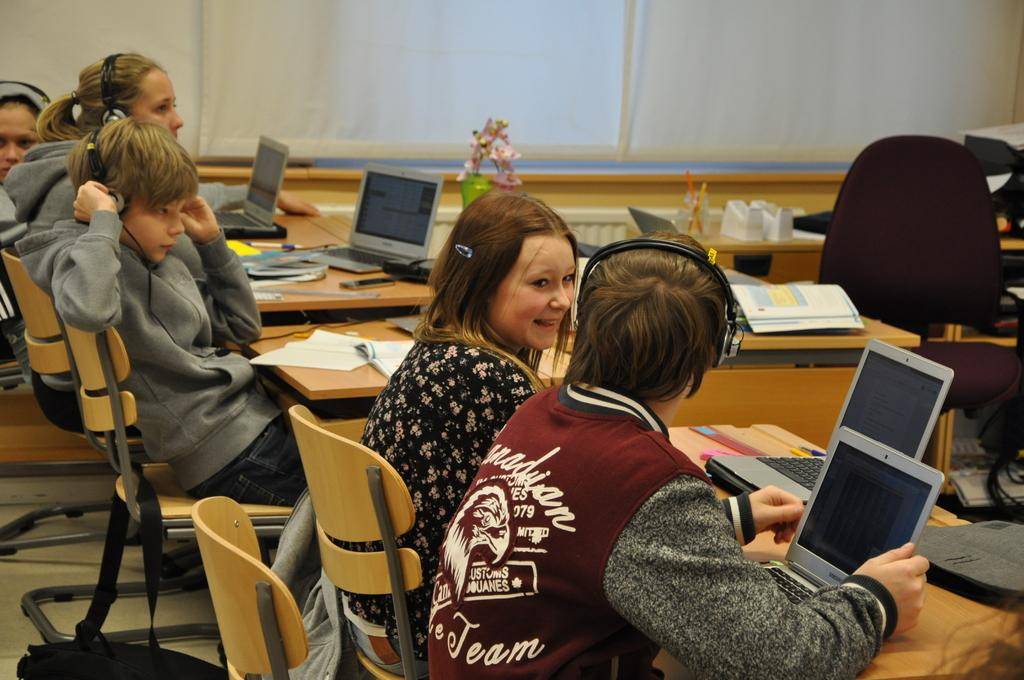What type of room is shown in the image? The image is taken in a classroom. What furniture is present in the classroom? There are tables and chairs in the image. What learning materials can be seen in the image? There are books and a laptop in the image. Are there any people in the classroom? Yes, there are people in the image. What additional items can be seen in the image? There are headphones and other objects in the image. What can be seen in the background of the image? There are window blinds in the background of the image. How does the cushion in the image express disgust? There is no cushion present in the image, and therefore it cannot express any emotions. 